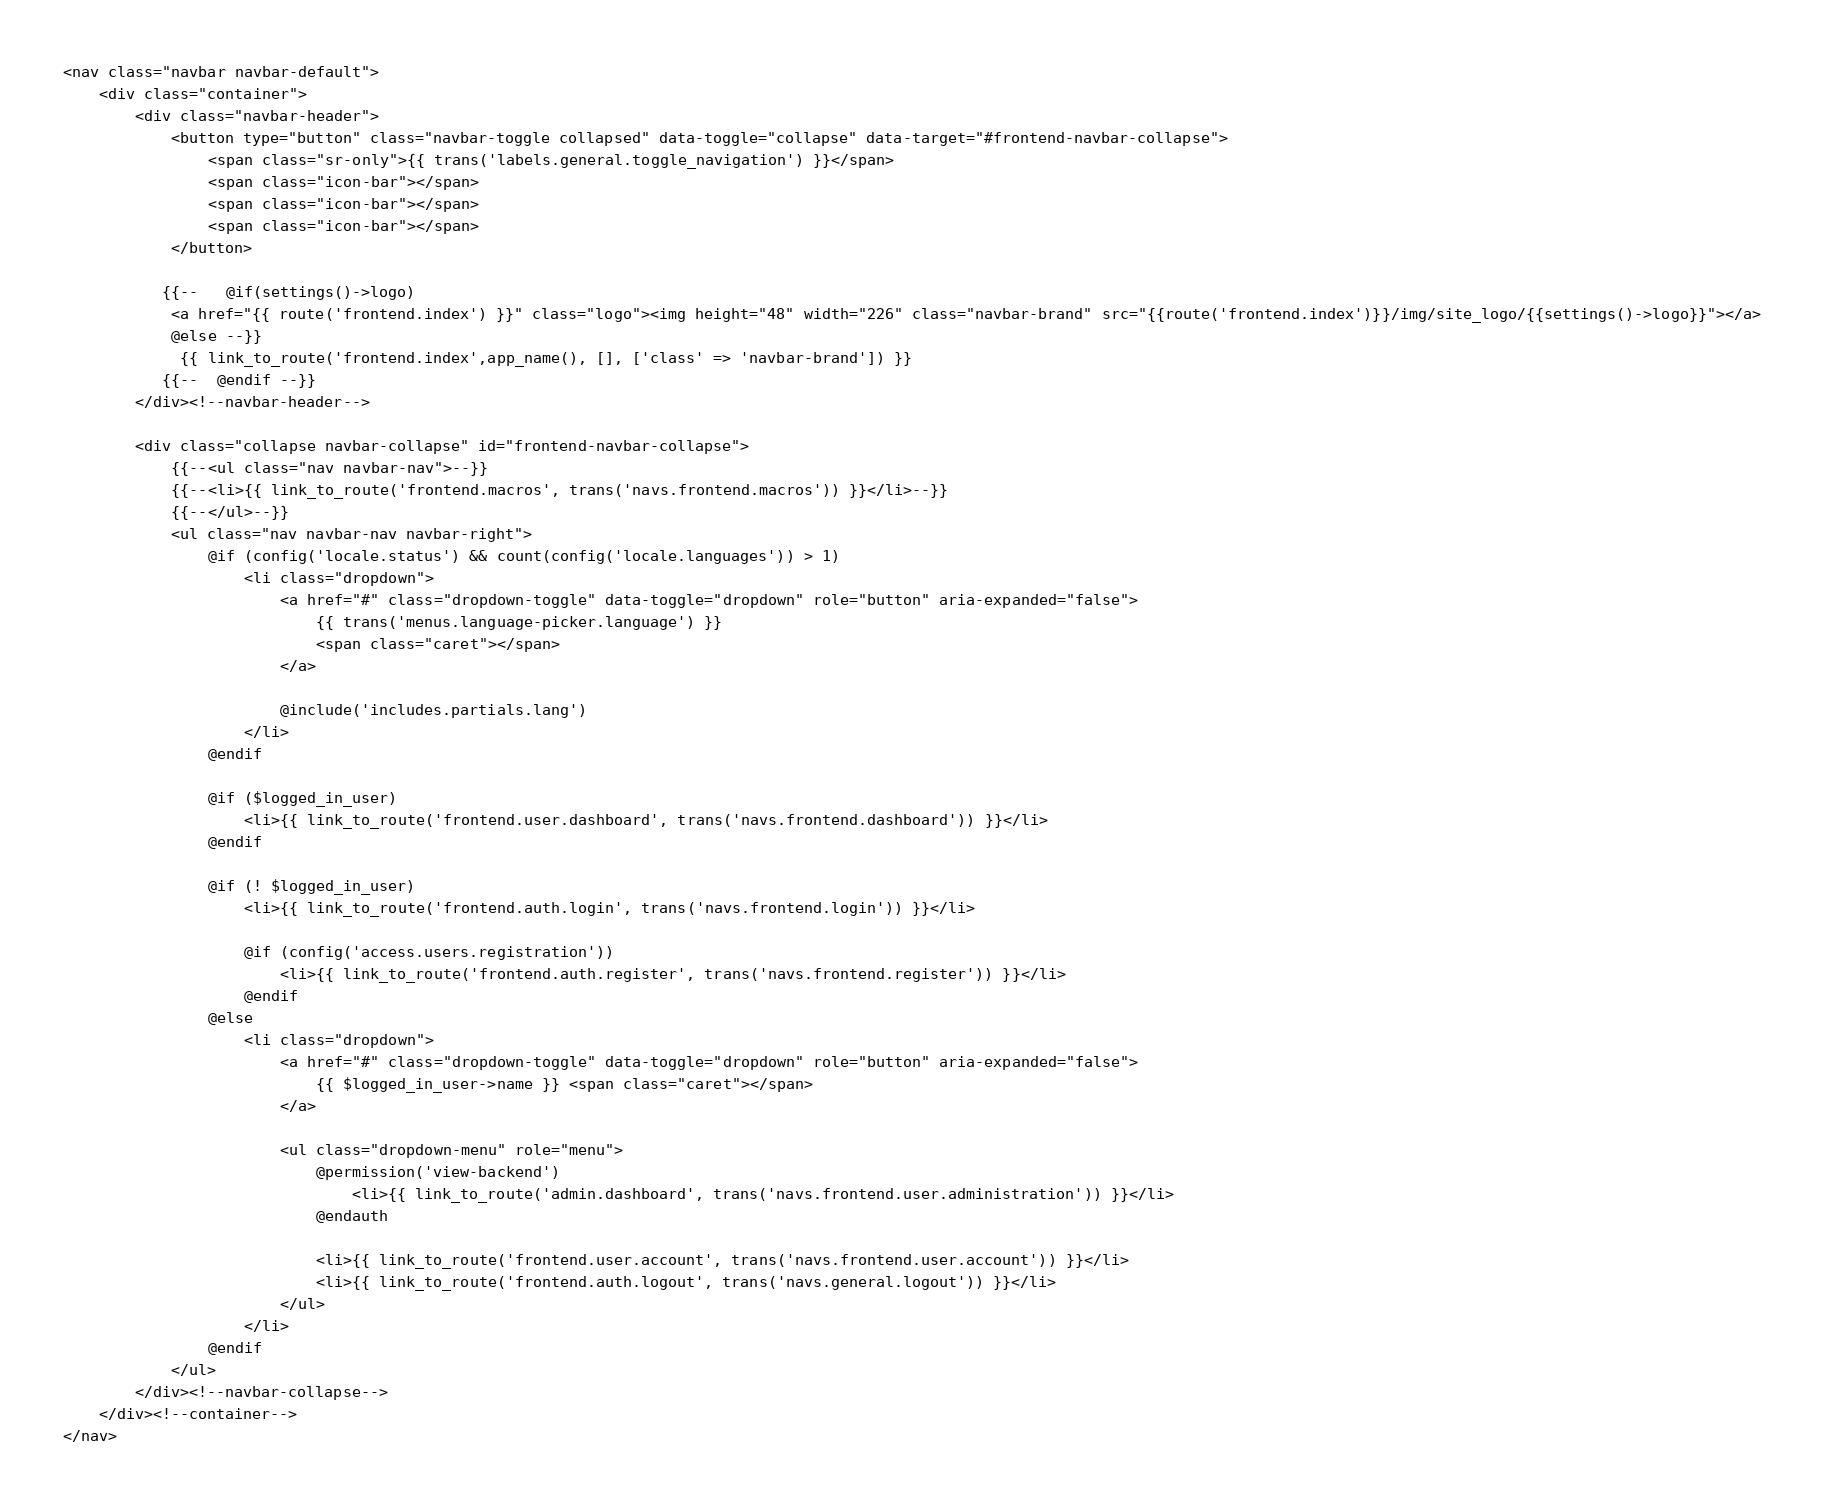Convert code to text. <code><loc_0><loc_0><loc_500><loc_500><_PHP_><nav class="navbar navbar-default">
    <div class="container">
        <div class="navbar-header">
            <button type="button" class="navbar-toggle collapsed" data-toggle="collapse" data-target="#frontend-navbar-collapse">
                <span class="sr-only">{{ trans('labels.general.toggle_navigation') }}</span>
                <span class="icon-bar"></span>
                <span class="icon-bar"></span>
                <span class="icon-bar"></span>
            </button>

           {{--   @if(settings()->logo)
            <a href="{{ route('frontend.index') }}" class="logo"><img height="48" width="226" class="navbar-brand" src="{{route('frontend.index')}}/img/site_logo/{{settings()->logo}}"></a>
            @else --}}
             {{ link_to_route('frontend.index',app_name(), [], ['class' => 'navbar-brand']) }}
           {{--  @endif --}}
        </div><!--navbar-header-->

        <div class="collapse navbar-collapse" id="frontend-navbar-collapse">
            {{--<ul class="nav navbar-nav">--}}
            {{--<li>{{ link_to_route('frontend.macros', trans('navs.frontend.macros')) }}</li>--}}
            {{--</ul>--}}
            <ul class="nav navbar-nav navbar-right">
                @if (config('locale.status') && count(config('locale.languages')) > 1)
                    <li class="dropdown">
                        <a href="#" class="dropdown-toggle" data-toggle="dropdown" role="button" aria-expanded="false">
                            {{ trans('menus.language-picker.language') }}
                            <span class="caret"></span>
                        </a>

                        @include('includes.partials.lang')
                    </li>
                @endif

                @if ($logged_in_user)
                    <li>{{ link_to_route('frontend.user.dashboard', trans('navs.frontend.dashboard')) }}</li>
                @endif

                @if (! $logged_in_user)
                    <li>{{ link_to_route('frontend.auth.login', trans('navs.frontend.login')) }}</li>

                    @if (config('access.users.registration'))
                        <li>{{ link_to_route('frontend.auth.register', trans('navs.frontend.register')) }}</li>
                    @endif
                @else
                    <li class="dropdown">
                        <a href="#" class="dropdown-toggle" data-toggle="dropdown" role="button" aria-expanded="false">
                            {{ $logged_in_user->name }} <span class="caret"></span>
                        </a>

                        <ul class="dropdown-menu" role="menu">
                            @permission('view-backend')
                                <li>{{ link_to_route('admin.dashboard', trans('navs.frontend.user.administration')) }}</li>
                            @endauth

                            <li>{{ link_to_route('frontend.user.account', trans('navs.frontend.user.account')) }}</li>
                            <li>{{ link_to_route('frontend.auth.logout', trans('navs.general.logout')) }}</li>
                        </ul>
                    </li>
                @endif
            </ul>
        </div><!--navbar-collapse-->
    </div><!--container-->
</nav></code> 